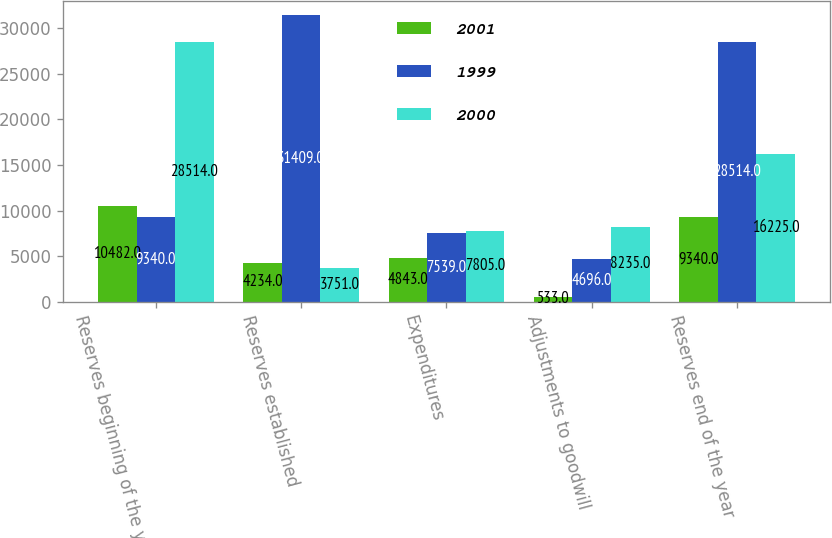Convert chart to OTSL. <chart><loc_0><loc_0><loc_500><loc_500><stacked_bar_chart><ecel><fcel>Reserves beginning of the year<fcel>Reserves established<fcel>Expenditures<fcel>Adjustments to goodwill<fcel>Reserves end of the year<nl><fcel>2001<fcel>10482<fcel>4234<fcel>4843<fcel>533<fcel>9340<nl><fcel>1999<fcel>9340<fcel>31409<fcel>7539<fcel>4696<fcel>28514<nl><fcel>2000<fcel>28514<fcel>3751<fcel>7805<fcel>8235<fcel>16225<nl></chart> 